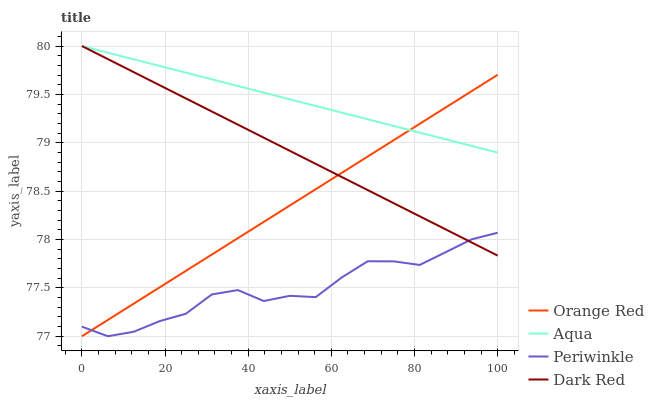Does Orange Red have the minimum area under the curve?
Answer yes or no. No. Does Orange Red have the maximum area under the curve?
Answer yes or no. No. Is Aqua the smoothest?
Answer yes or no. No. Is Aqua the roughest?
Answer yes or no. No. Does Aqua have the lowest value?
Answer yes or no. No. Does Orange Red have the highest value?
Answer yes or no. No. Is Periwinkle less than Aqua?
Answer yes or no. Yes. Is Aqua greater than Periwinkle?
Answer yes or no. Yes. Does Periwinkle intersect Aqua?
Answer yes or no. No. 